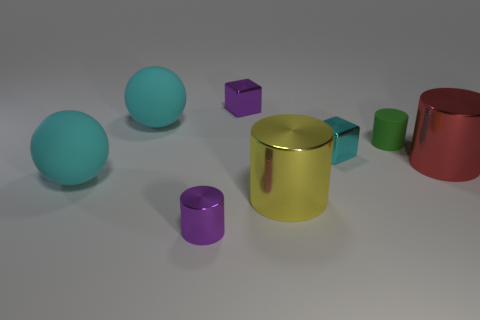There is a purple object that is behind the tiny object that is on the left side of the tiny purple block; what is its size?
Make the answer very short. Small. How many objects are small cylinders behind the small purple cylinder or small blue cubes?
Make the answer very short. 1. Are there any red rubber objects of the same size as the yellow metal cylinder?
Give a very brief answer. No. There is a purple object that is to the right of the purple metal cylinder; are there any purple objects on the right side of it?
Make the answer very short. No. What number of cylinders are either tiny green things or yellow things?
Provide a short and direct response. 2. Are there any other yellow things that have the same shape as the large yellow thing?
Give a very brief answer. No. What shape is the yellow thing?
Your answer should be compact. Cylinder. What number of things are either brown metal spheres or purple blocks?
Make the answer very short. 1. Do the shiny cylinder that is behind the big yellow thing and the rubber ball that is behind the large red thing have the same size?
Your response must be concise. Yes. How many other things are made of the same material as the cyan block?
Give a very brief answer. 4. 